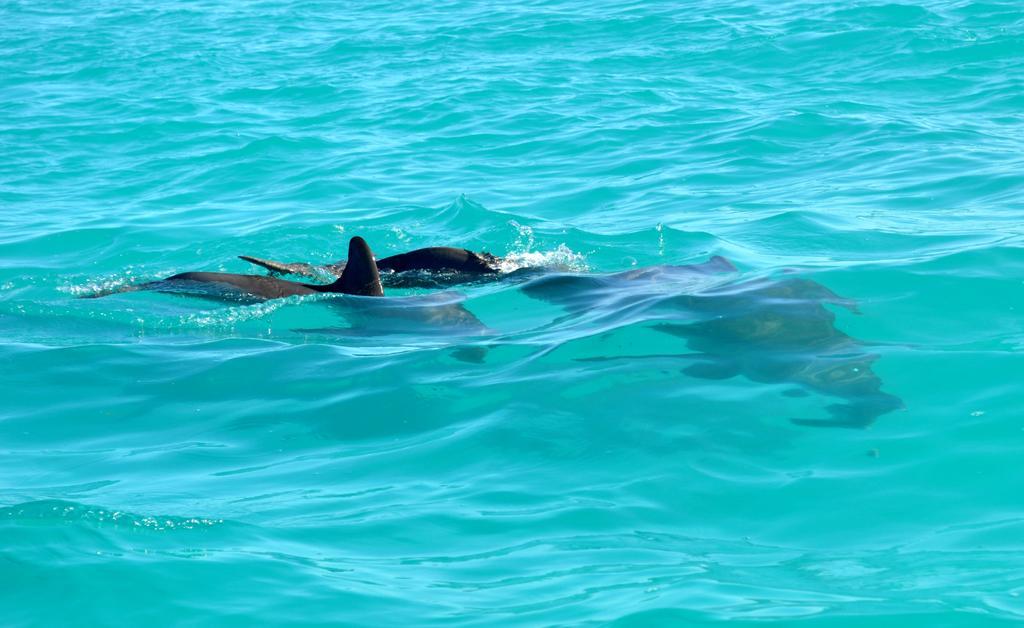In one or two sentences, can you explain what this image depicts? In this image we can see the dolphins in a water body. 